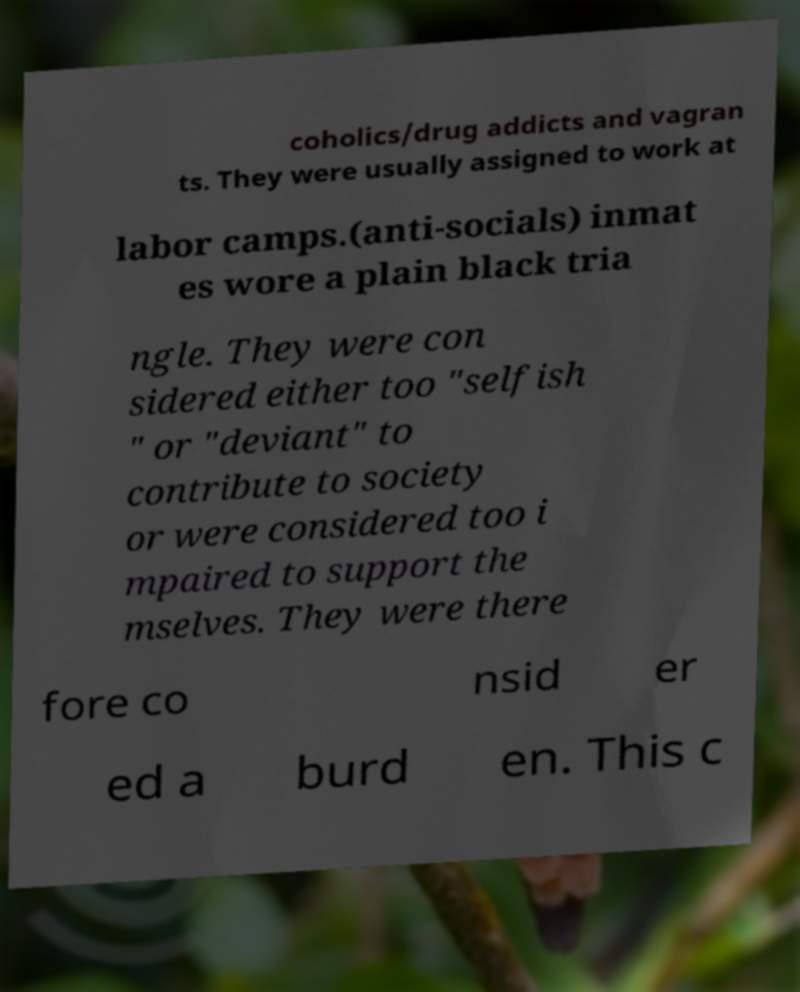Could you extract and type out the text from this image? coholics/drug addicts and vagran ts. They were usually assigned to work at labor camps.(anti-socials) inmat es wore a plain black tria ngle. They were con sidered either too "selfish " or "deviant" to contribute to society or were considered too i mpaired to support the mselves. They were there fore co nsid er ed a burd en. This c 